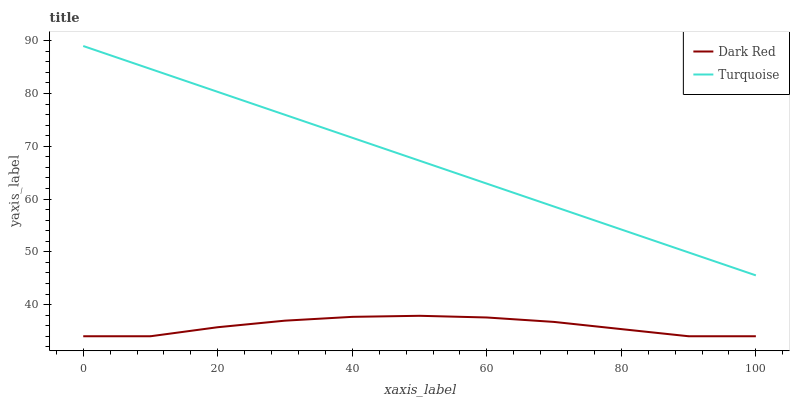Does Dark Red have the minimum area under the curve?
Answer yes or no. Yes. Does Turquoise have the maximum area under the curve?
Answer yes or no. Yes. Does Turquoise have the minimum area under the curve?
Answer yes or no. No. Is Turquoise the smoothest?
Answer yes or no. Yes. Is Dark Red the roughest?
Answer yes or no. Yes. Is Turquoise the roughest?
Answer yes or no. No. Does Dark Red have the lowest value?
Answer yes or no. Yes. Does Turquoise have the lowest value?
Answer yes or no. No. Does Turquoise have the highest value?
Answer yes or no. Yes. Is Dark Red less than Turquoise?
Answer yes or no. Yes. Is Turquoise greater than Dark Red?
Answer yes or no. Yes. Does Dark Red intersect Turquoise?
Answer yes or no. No. 